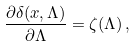<formula> <loc_0><loc_0><loc_500><loc_500>\frac { \partial \delta ( { x } , \Lambda ) } { \partial \Lambda } = \zeta ( \Lambda ) \, ,</formula> 